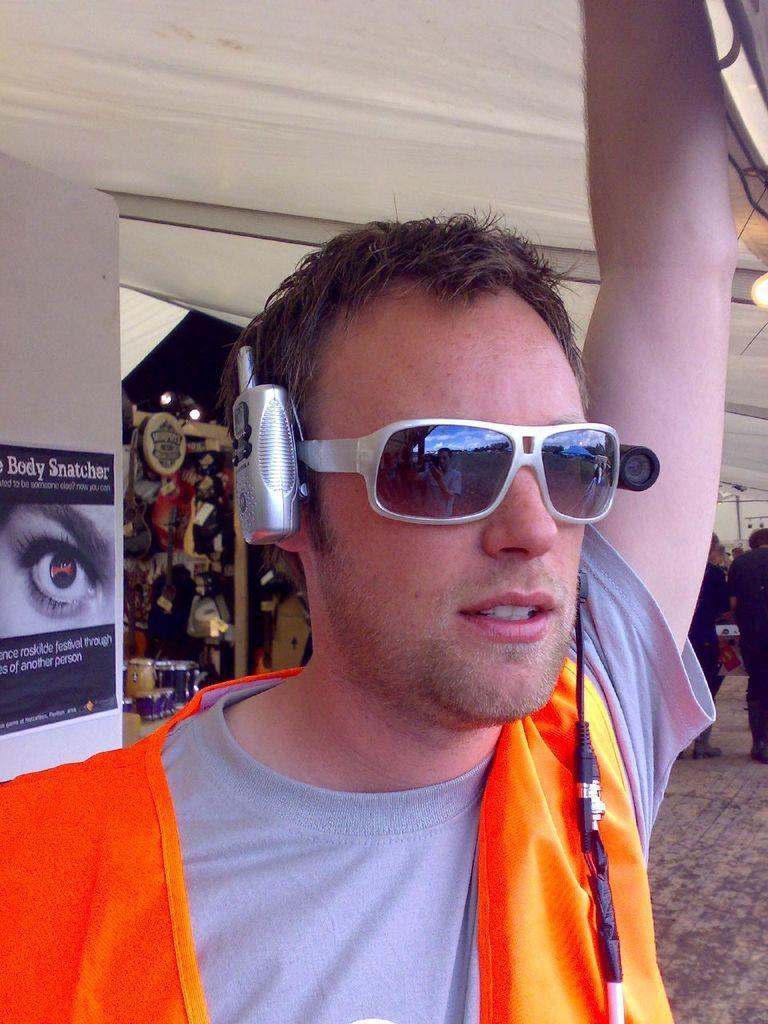In one or two sentences, can you explain what this image depicts? In this picture I can see a person wearing spectacles and posters to the wall. 